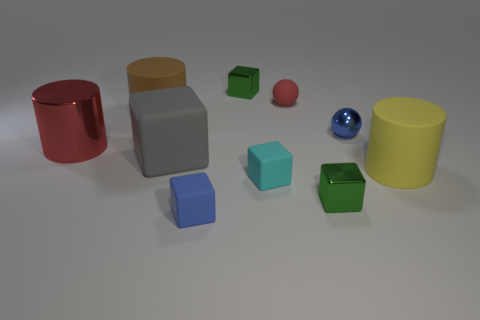Subtract all small blue blocks. How many blocks are left? 4 Subtract all blue blocks. How many blocks are left? 4 Add 8 yellow matte blocks. How many yellow matte blocks exist? 8 Subtract 0 cyan cylinders. How many objects are left? 10 Subtract all balls. How many objects are left? 8 Subtract 1 spheres. How many spheres are left? 1 Subtract all red cubes. Subtract all cyan spheres. How many cubes are left? 5 Subtract all red balls. How many brown cylinders are left? 1 Subtract all metal balls. Subtract all big cyan spheres. How many objects are left? 9 Add 4 big gray matte cubes. How many big gray matte cubes are left? 5 